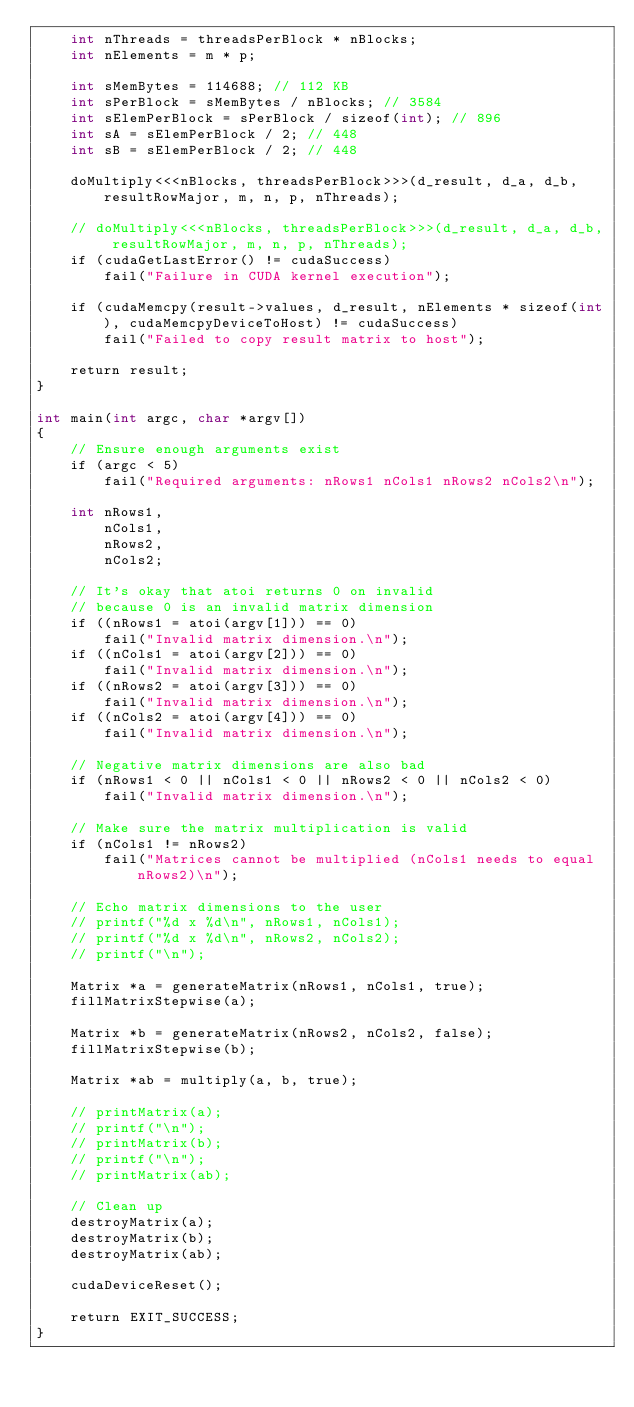<code> <loc_0><loc_0><loc_500><loc_500><_Cuda_>    int nThreads = threadsPerBlock * nBlocks;
    int nElements = m * p;

    int sMemBytes = 114688; // 112 KB
    int sPerBlock = sMemBytes / nBlocks; // 3584
    int sElemPerBlock = sPerBlock / sizeof(int); // 896
    int sA = sElemPerBlock / 2; // 448
    int sB = sElemPerBlock / 2; // 448
    
    doMultiply<<<nBlocks, threadsPerBlock>>>(d_result, d_a, d_b, resultRowMajor, m, n, p, nThreads);

    // doMultiply<<<nBlocks, threadsPerBlock>>>(d_result, d_a, d_b, resultRowMajor, m, n, p, nThreads);
    if (cudaGetLastError() != cudaSuccess)
        fail("Failure in CUDA kernel execution");
    
    if (cudaMemcpy(result->values, d_result, nElements * sizeof(int), cudaMemcpyDeviceToHost) != cudaSuccess)
        fail("Failed to copy result matrix to host");

    return result;
}

int main(int argc, char *argv[])
{
    // Ensure enough arguments exist
    if (argc < 5)
        fail("Required arguments: nRows1 nCols1 nRows2 nCols2\n");

    int nRows1,
        nCols1,
        nRows2,
        nCols2;

    // It's okay that atoi returns 0 on invalid
    // because 0 is an invalid matrix dimension
    if ((nRows1 = atoi(argv[1])) == 0)
        fail("Invalid matrix dimension.\n");
    if ((nCols1 = atoi(argv[2])) == 0)
        fail("Invalid matrix dimension.\n");
    if ((nRows2 = atoi(argv[3])) == 0)
        fail("Invalid matrix dimension.\n");
    if ((nCols2 = atoi(argv[4])) == 0)
        fail("Invalid matrix dimension.\n");

    // Negative matrix dimensions are also bad
    if (nRows1 < 0 || nCols1 < 0 || nRows2 < 0 || nCols2 < 0)
        fail("Invalid matrix dimension.\n");
    
    // Make sure the matrix multiplication is valid
    if (nCols1 != nRows2)
        fail("Matrices cannot be multiplied (nCols1 needs to equal nRows2)\n");

    // Echo matrix dimensions to the user
    // printf("%d x %d\n", nRows1, nCols1);
    // printf("%d x %d\n", nRows2, nCols2);
    // printf("\n");

    Matrix *a = generateMatrix(nRows1, nCols1, true);
    fillMatrixStepwise(a);
    
    Matrix *b = generateMatrix(nRows2, nCols2, false);
    fillMatrixStepwise(b);

    Matrix *ab = multiply(a, b, true);

    // printMatrix(a);
    // printf("\n");
    // printMatrix(b);
    // printf("\n");
    // printMatrix(ab);

    // Clean up
    destroyMatrix(a);
    destroyMatrix(b);
    destroyMatrix(ab);
    
    cudaDeviceReset();

    return EXIT_SUCCESS;
}</code> 